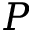Convert formula to latex. <formula><loc_0><loc_0><loc_500><loc_500>P</formula> 